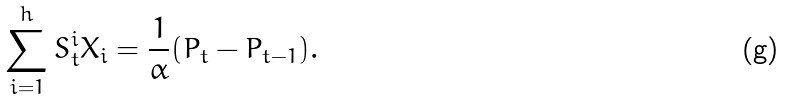<formula> <loc_0><loc_0><loc_500><loc_500>\sum _ { i = 1 } ^ { h } S ^ { i } _ { t } X _ { i } = \frac { 1 } { \alpha } ( P _ { t } - P _ { t - 1 } ) .</formula> 